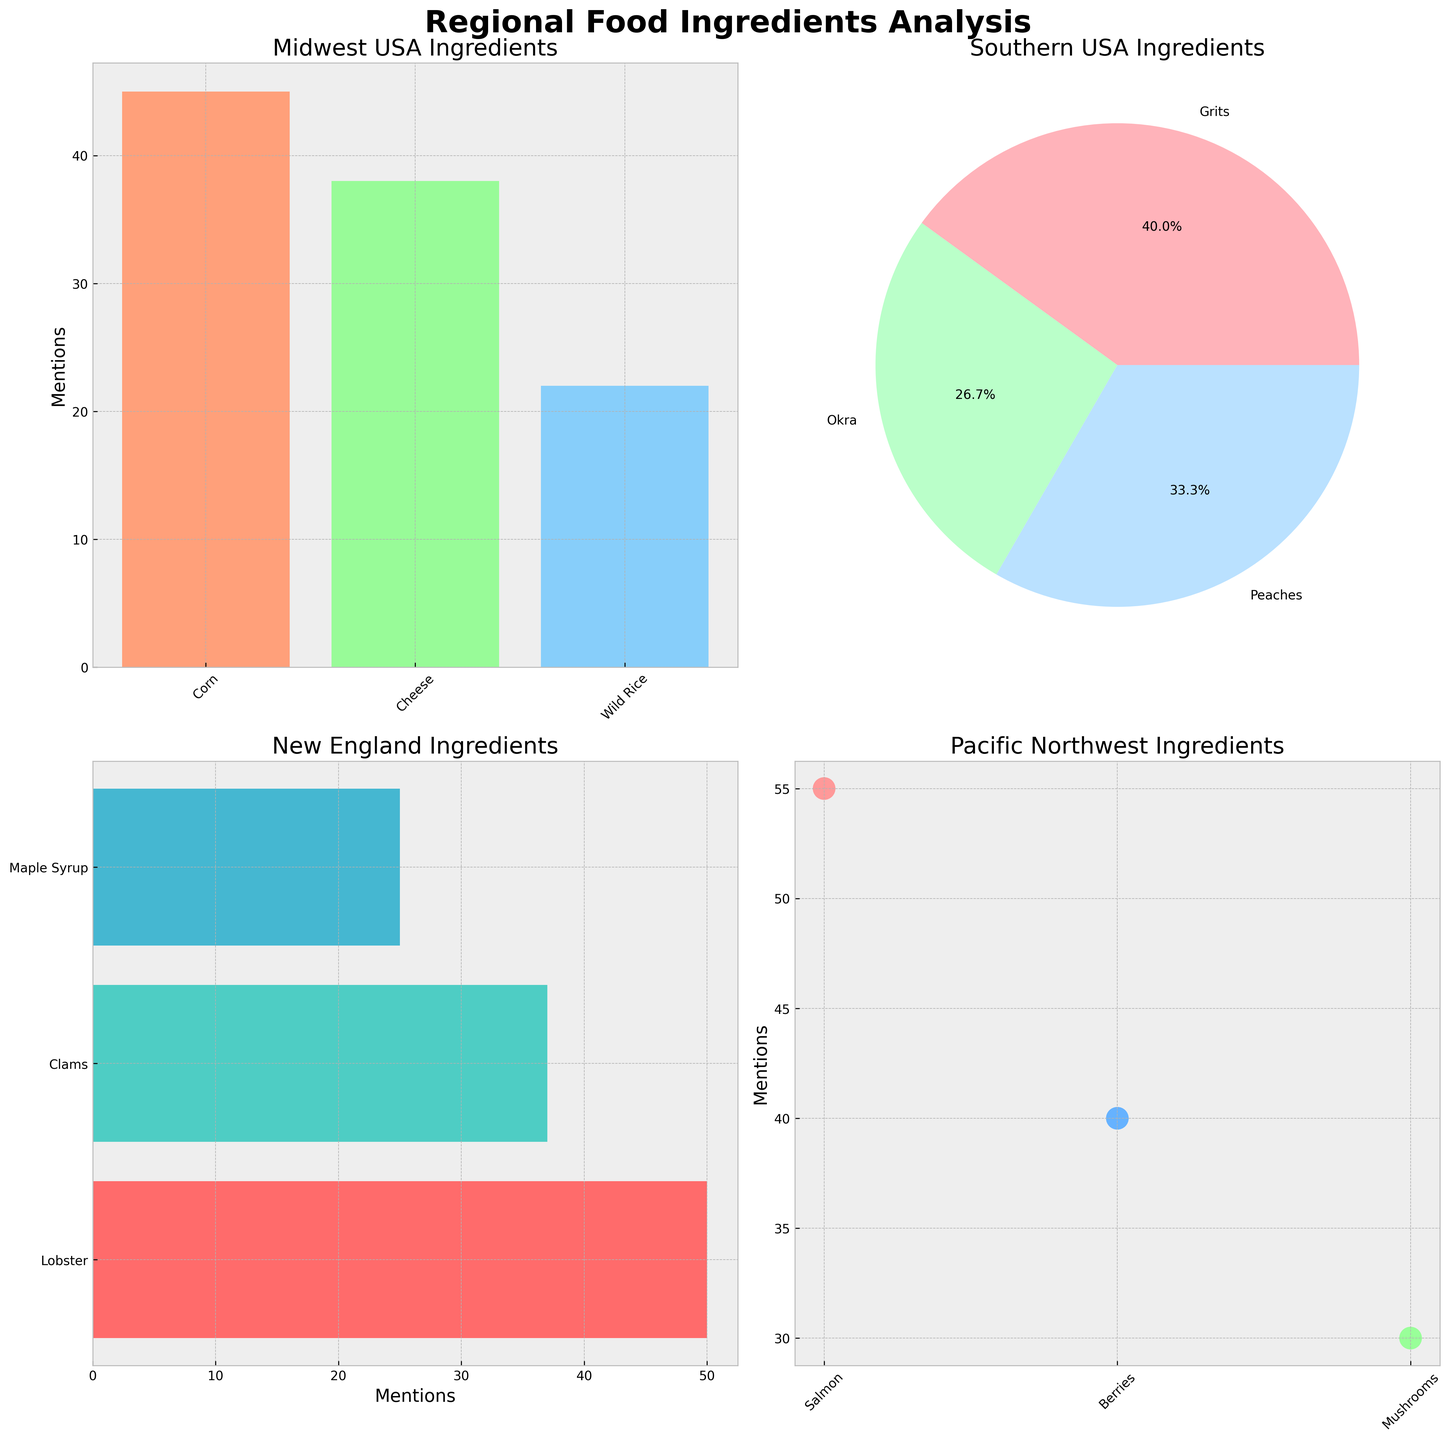What's the most mentioned ingredient in the Pacific Northwest? From the scatter plot for Pacific Northwest, the data point representing 'Salmon' has the highest value on the y-axis indicating mentions.
Answer: Salmon How many ingredients were mentioned in the Midwest USA region? The bar chart for Midwest USA shows the number of bars, each representing an ingredient. There are 3 bars.
Answer: 3 What percentage of mentions does Okra have in the Southern USA region? The pie chart for Southern USA can be used to find this. The segment for 'Okra' has a label that indicates 28%.
Answer: 28% Which region has the most mentions for an individual ingredient? To determine this, we look at all subplots and find the highest value. The scatter plot for Pacific Northwest shows 'Salmon' with 55 mentions.
Answer: Pacific Northwest What is the total number of mentions for New England ingredients? From the horizontal bar chart for New England, we add the values for each ingredient: Lobster (50) + Clams (37) + Maple Syrup (25). This totals 112.
Answer: 112 How many mentions does Avocado have in California? The bar chart for California shows the height of the bar for Avocado which is 60.
Answer: 60 Which has more mentions, Cheese in Midwest USA or Beans in Southwest? Comparing the bars from Midwest USA and Southwest, Cheese has 38 mentions, while Beans has 39. Beans has more mentions by 1.
Answer: Beans What's the title of the subplot for Southern USA? The title can be found above the pie chart for Southern USA, which reads 'Southern USA Ingredients'.
Answer: Southern USA Ingredients What are the ingredient colors for the Midwest USA region? The bar chart for Midwest USA shows the colors: Corn is salmon (#FFA07A), Cheese is light green (#98FB98), and Wild Rice is light blue (#87CEFA).
Answer: Salmon, Light Green, Light Blue Which ingredient has the least mentions in the Southern USA region? From the pie chart, we can see that 'Okra' has the smallest segment, indicating the fewest mentions.
Answer: Okra 